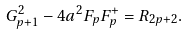<formula> <loc_0><loc_0><loc_500><loc_500>G ^ { 2 } _ { p + 1 } - 4 a ^ { 2 } F _ { p } F ^ { + } _ { p } = R _ { 2 p + 2 } .</formula> 